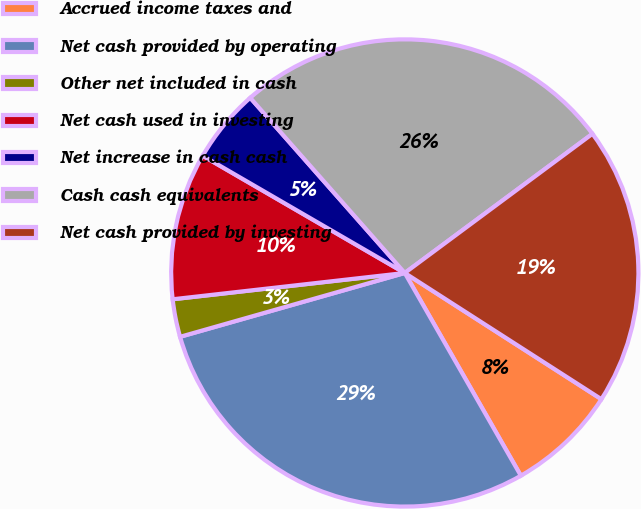Convert chart to OTSL. <chart><loc_0><loc_0><loc_500><loc_500><pie_chart><fcel>Accrued income taxes and<fcel>Net cash provided by operating<fcel>Other net included in cash<fcel>Net cash used in investing<fcel>Net increase in cash cash<fcel>Cash cash equivalents<fcel>Net cash provided by investing<nl><fcel>7.64%<fcel>28.87%<fcel>2.61%<fcel>10.16%<fcel>5.13%<fcel>26.35%<fcel>19.24%<nl></chart> 